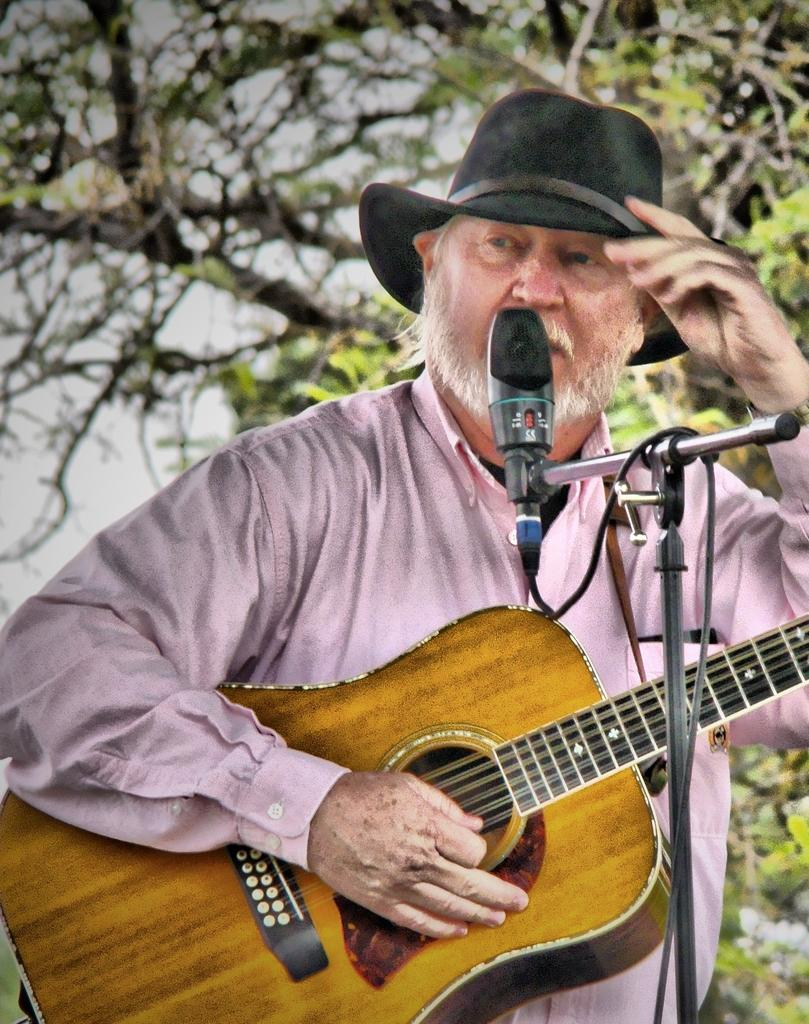What is the man in the image holding? The man is holding a guitar. What object is in front of the man? There is a microphone in front of the man. What can be seen in the background of the image? Trees are visible in the background of the image. How many ducks are sitting on the man's arm in the image? There are no ducks present in the image, and the man's arm is not visible. 